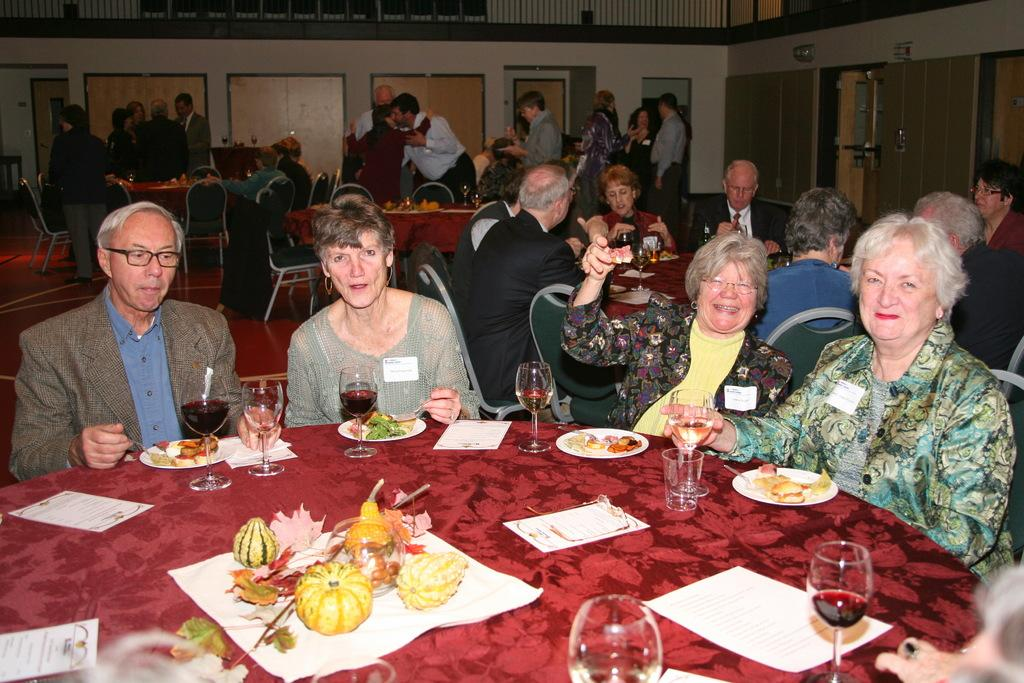What are the persons in the image doing? Some persons are sitting on chairs, while others are standing. What can be seen on the tables in the image? There are plates, food, and glasses visible on the tables. What is present in the background of the image? There is a wall and a door in the background of the image. What type of vase can be seen on the table in the image? There is no vase present on the table in the image. Can you describe the twig that is being used as a decoration in the image? There is no twig being used as a decoration in the image. 